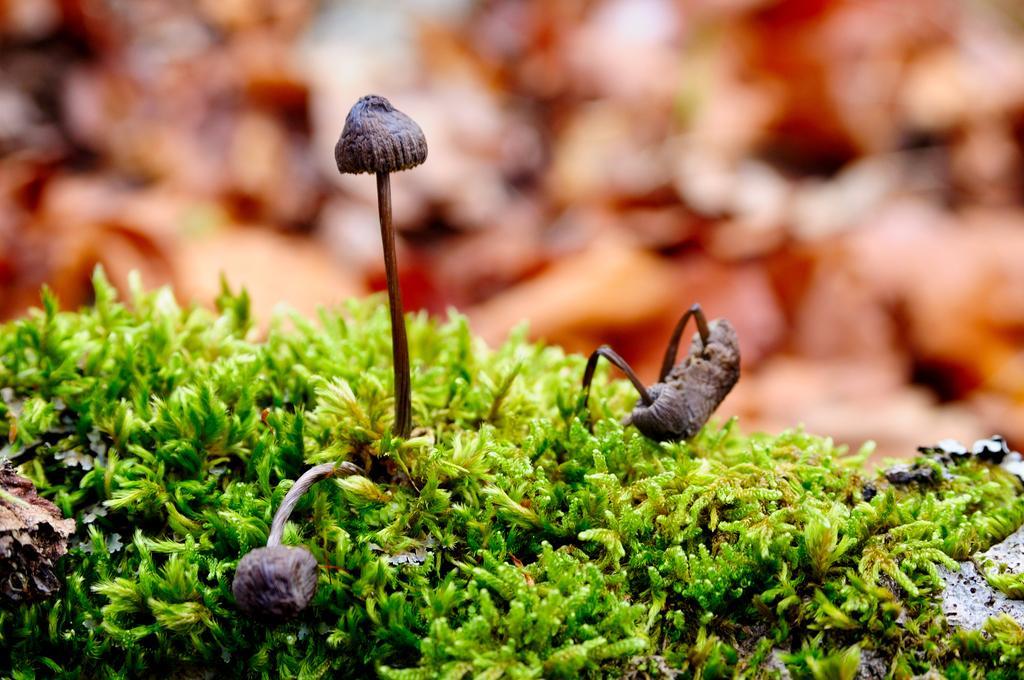Could you give a brief overview of what you see in this image? In this image I can see few mushrooms and the grass. I can see the blurred background. 